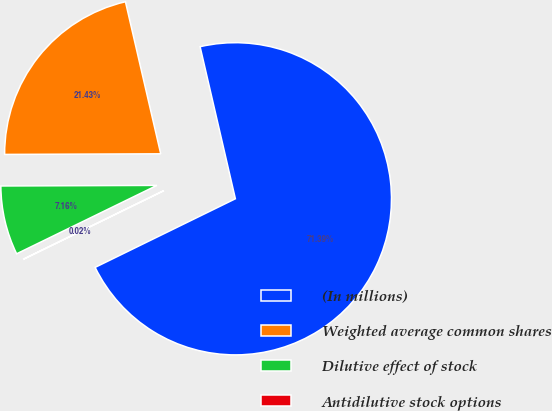Convert chart to OTSL. <chart><loc_0><loc_0><loc_500><loc_500><pie_chart><fcel>(In millions)<fcel>Weighted average common shares<fcel>Dilutive effect of stock<fcel>Antidilutive stock options<nl><fcel>71.38%<fcel>21.43%<fcel>7.16%<fcel>0.02%<nl></chart> 